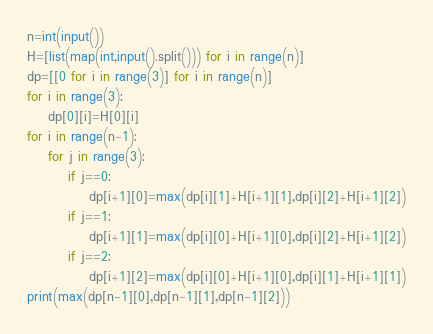<code> <loc_0><loc_0><loc_500><loc_500><_Python_>n=int(input())
H=[list(map(int,input().split())) for i in range(n)]
dp=[[0 for i in range(3)] for i in range(n)]
for i in range(3):
    dp[0][i]=H[0][i]
for i in range(n-1):
    for j in range(3):
        if j==0:
            dp[i+1][0]=max(dp[i][1]+H[i+1][1],dp[i][2]+H[i+1][2])
        if j==1:
            dp[i+1][1]=max(dp[i][0]+H[i+1][0],dp[i][2]+H[i+1][2])
        if j==2:
            dp[i+1][2]=max(dp[i][0]+H[i+1][0],dp[i][1]+H[i+1][1])
print(max(dp[n-1][0],dp[n-1][1],dp[n-1][2]))</code> 